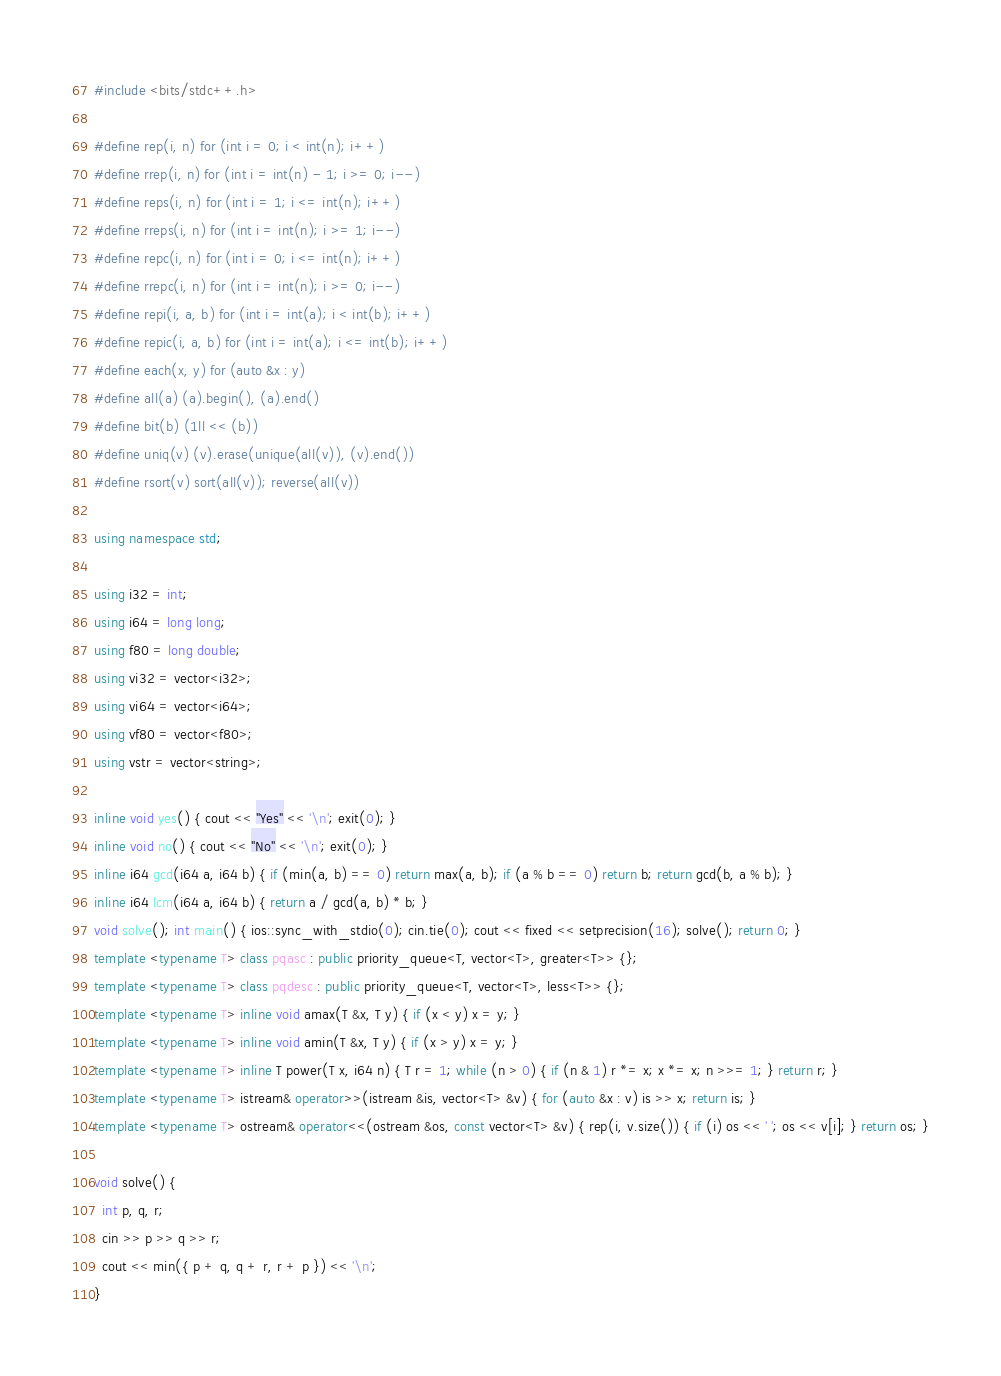Convert code to text. <code><loc_0><loc_0><loc_500><loc_500><_C++_>#include <bits/stdc++.h>

#define rep(i, n) for (int i = 0; i < int(n); i++)
#define rrep(i, n) for (int i = int(n) - 1; i >= 0; i--)
#define reps(i, n) for (int i = 1; i <= int(n); i++)
#define rreps(i, n) for (int i = int(n); i >= 1; i--)
#define repc(i, n) for (int i = 0; i <= int(n); i++)
#define rrepc(i, n) for (int i = int(n); i >= 0; i--)
#define repi(i, a, b) for (int i = int(a); i < int(b); i++)
#define repic(i, a, b) for (int i = int(a); i <= int(b); i++)
#define each(x, y) for (auto &x : y)
#define all(a) (a).begin(), (a).end()
#define bit(b) (1ll << (b))
#define uniq(v) (v).erase(unique(all(v)), (v).end())
#define rsort(v) sort(all(v)); reverse(all(v))

using namespace std;

using i32 = int;
using i64 = long long;
using f80 = long double;
using vi32 = vector<i32>;
using vi64 = vector<i64>;
using vf80 = vector<f80>;
using vstr = vector<string>;

inline void yes() { cout << "Yes" << '\n'; exit(0); }
inline void no() { cout << "No" << '\n'; exit(0); }
inline i64 gcd(i64 a, i64 b) { if (min(a, b) == 0) return max(a, b); if (a % b == 0) return b; return gcd(b, a % b); }
inline i64 lcm(i64 a, i64 b) { return a / gcd(a, b) * b; }
void solve(); int main() { ios::sync_with_stdio(0); cin.tie(0); cout << fixed << setprecision(16); solve(); return 0; }
template <typename T> class pqasc : public priority_queue<T, vector<T>, greater<T>> {};
template <typename T> class pqdesc : public priority_queue<T, vector<T>, less<T>> {};
template <typename T> inline void amax(T &x, T y) { if (x < y) x = y; }
template <typename T> inline void amin(T &x, T y) { if (x > y) x = y; }
template <typename T> inline T power(T x, i64 n) { T r = 1; while (n > 0) { if (n & 1) r *= x; x *= x; n >>= 1; } return r; }
template <typename T> istream& operator>>(istream &is, vector<T> &v) { for (auto &x : v) is >> x; return is; }
template <typename T> ostream& operator<<(ostream &os, const vector<T> &v) { rep(i, v.size()) { if (i) os << ' '; os << v[i]; } return os; }

void solve() {
  int p, q, r;
  cin >> p >> q >> r;
  cout << min({ p + q, q + r, r + p }) << '\n';
}
</code> 